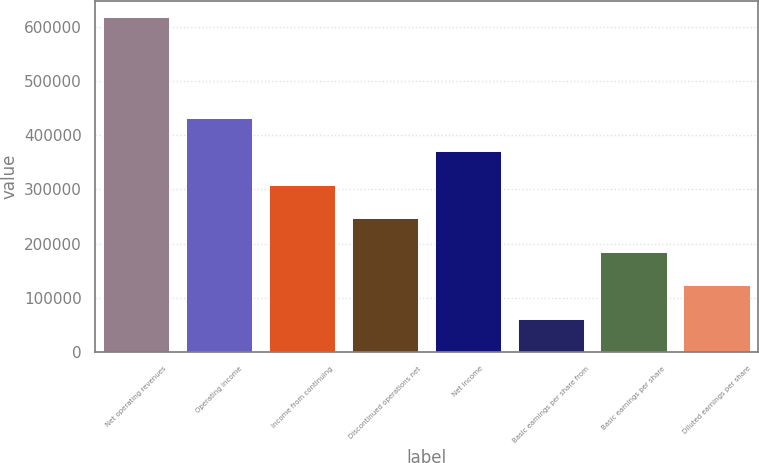Convert chart. <chart><loc_0><loc_0><loc_500><loc_500><bar_chart><fcel>Net operating revenues<fcel>Operating income<fcel>Income from continuing<fcel>Discontinued operations net<fcel>Net income<fcel>Basic earnings per share from<fcel>Basic earnings per share<fcel>Diluted earnings per share<nl><fcel>617085<fcel>431960<fcel>308543<fcel>246834<fcel>370251<fcel>61708.9<fcel>185126<fcel>123417<nl></chart> 